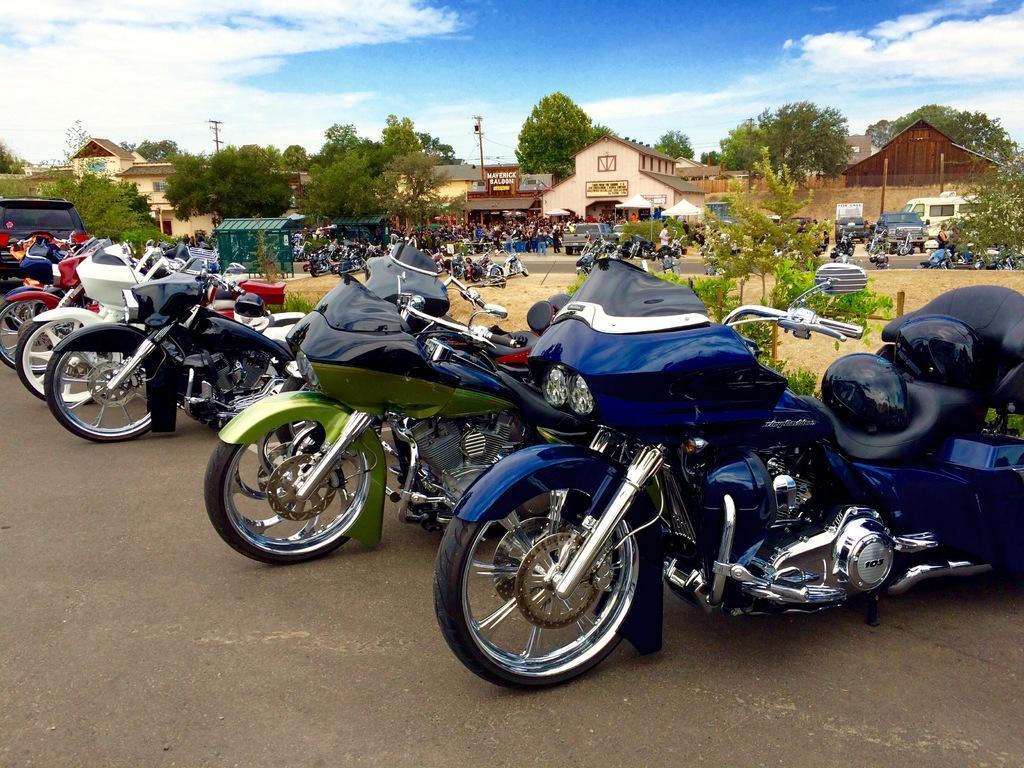In one or two sentences, can you explain what this image depicts? As we can see in the image there are motor cycles, buildings, few people here and there, trees, current poles and on the top there is a sky. 